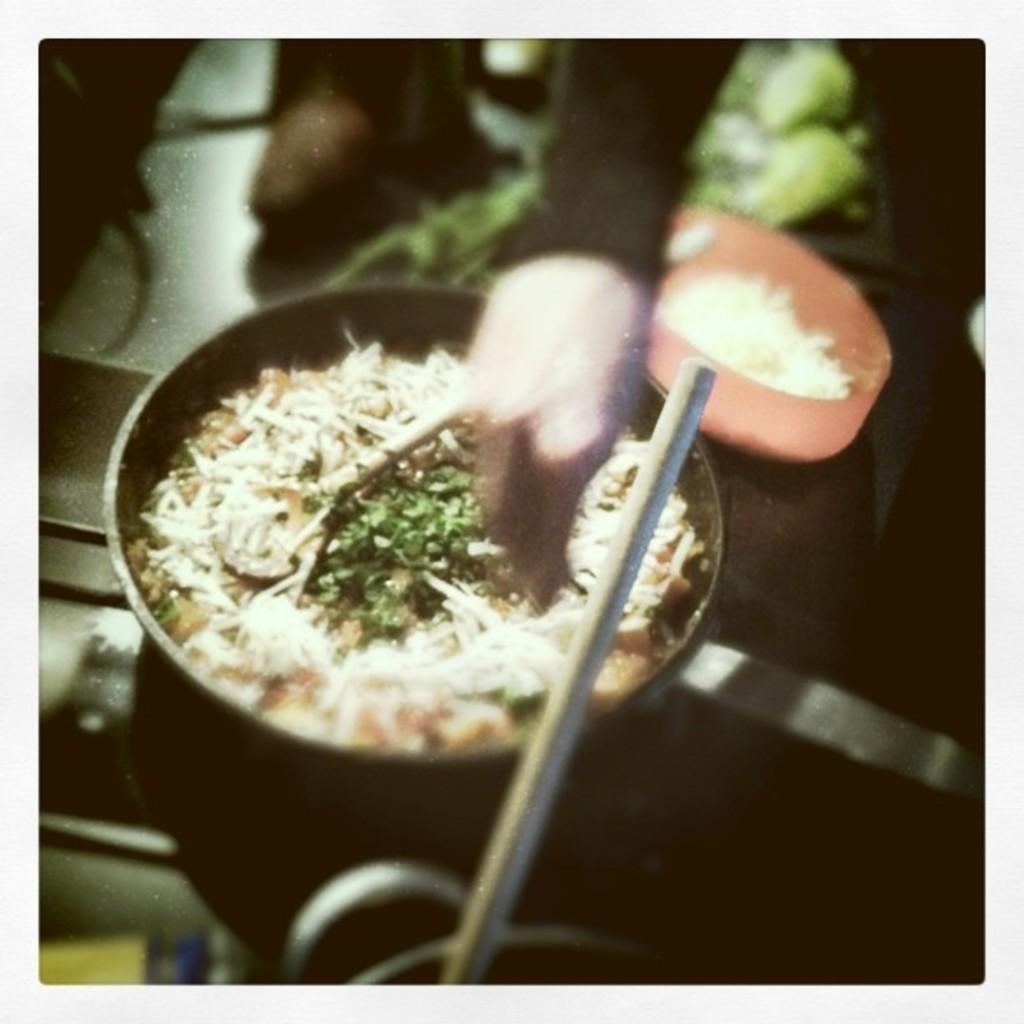How would you summarize this image in a sentence or two? In this image, we can see a person's hand and there is a pan and a bowl with food are present. 